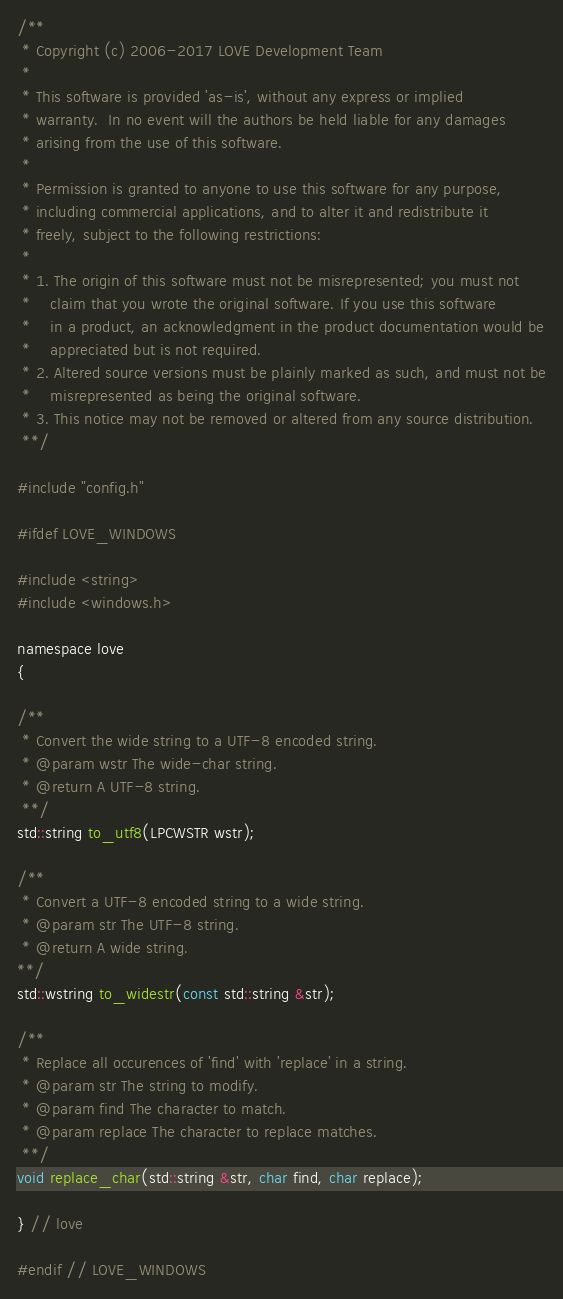Convert code to text. <code><loc_0><loc_0><loc_500><loc_500><_C_>/**
 * Copyright (c) 2006-2017 LOVE Development Team
 *
 * This software is provided 'as-is', without any express or implied
 * warranty.  In no event will the authors be held liable for any damages
 * arising from the use of this software.
 *
 * Permission is granted to anyone to use this software for any purpose,
 * including commercial applications, and to alter it and redistribute it
 * freely, subject to the following restrictions:
 *
 * 1. The origin of this software must not be misrepresented; you must not
 *    claim that you wrote the original software. If you use this software
 *    in a product, an acknowledgment in the product documentation would be
 *    appreciated but is not required.
 * 2. Altered source versions must be plainly marked as such, and must not be
 *    misrepresented as being the original software.
 * 3. This notice may not be removed or altered from any source distribution.
 **/

#include "config.h"

#ifdef LOVE_WINDOWS

#include <string>
#include <windows.h>

namespace love
{

/**
 * Convert the wide string to a UTF-8 encoded string.
 * @param wstr The wide-char string.
 * @return A UTF-8 string.
 **/
std::string to_utf8(LPCWSTR wstr);

/**
 * Convert a UTF-8 encoded string to a wide string.
 * @param str The UTF-8 string.
 * @return A wide string.
**/
std::wstring to_widestr(const std::string &str);

/**
 * Replace all occurences of 'find' with 'replace' in a string.
 * @param str The string to modify.
 * @param find The character to match.
 * @param replace The character to replace matches.
 **/
void replace_char(std::string &str, char find, char replace);

} // love

#endif // LOVE_WINDOWS
</code> 